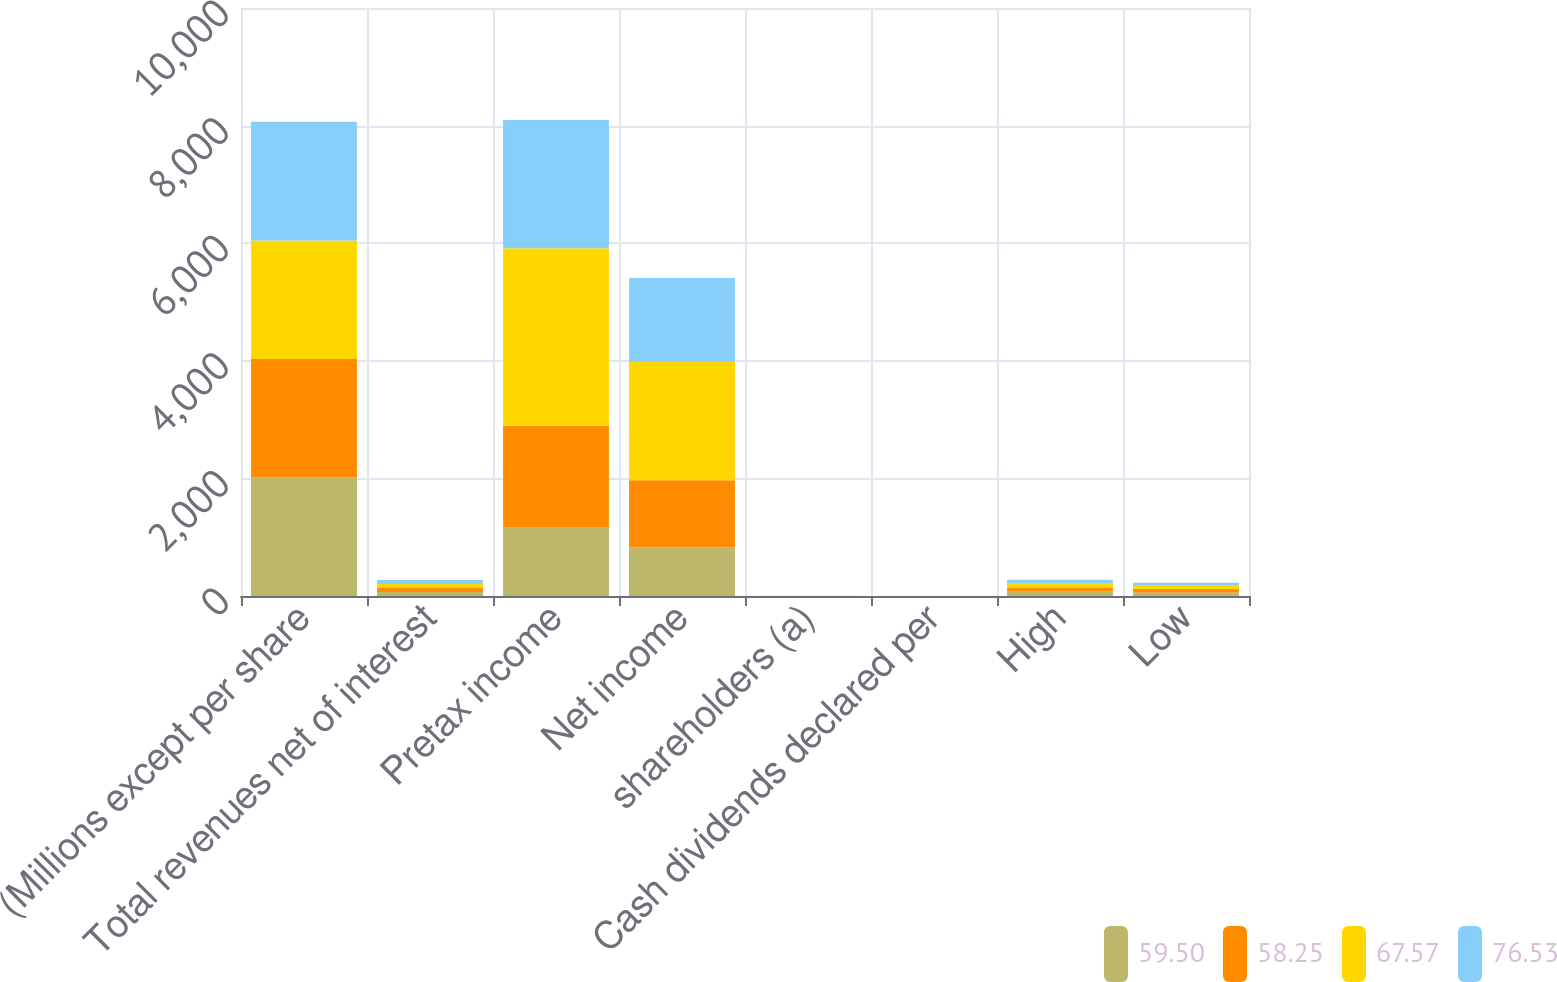<chart> <loc_0><loc_0><loc_500><loc_500><stacked_bar_chart><ecel><fcel>(Millions except per share<fcel>Total revenues net of interest<fcel>Pretax income<fcel>Net income<fcel>shareholders (a)<fcel>Cash dividends declared per<fcel>High<fcel>Low<nl><fcel>59.5<fcel>2016<fcel>67.76<fcel>1161<fcel>825<fcel>0.88<fcel>0.32<fcel>75.74<fcel>59.5<nl><fcel>58.25<fcel>2016<fcel>67.76<fcel>1735<fcel>1142<fcel>1.21<fcel>0.32<fcel>66.71<fcel>58.25<nl><fcel>67.57<fcel>2016<fcel>67.76<fcel>3016<fcel>2015<fcel>2.11<fcel>0.29<fcel>67.34<fcel>57.15<nl><fcel>76.53<fcel>2016<fcel>67.76<fcel>2184<fcel>1426<fcel>1.45<fcel>0.29<fcel>68.18<fcel>50.27<nl></chart> 